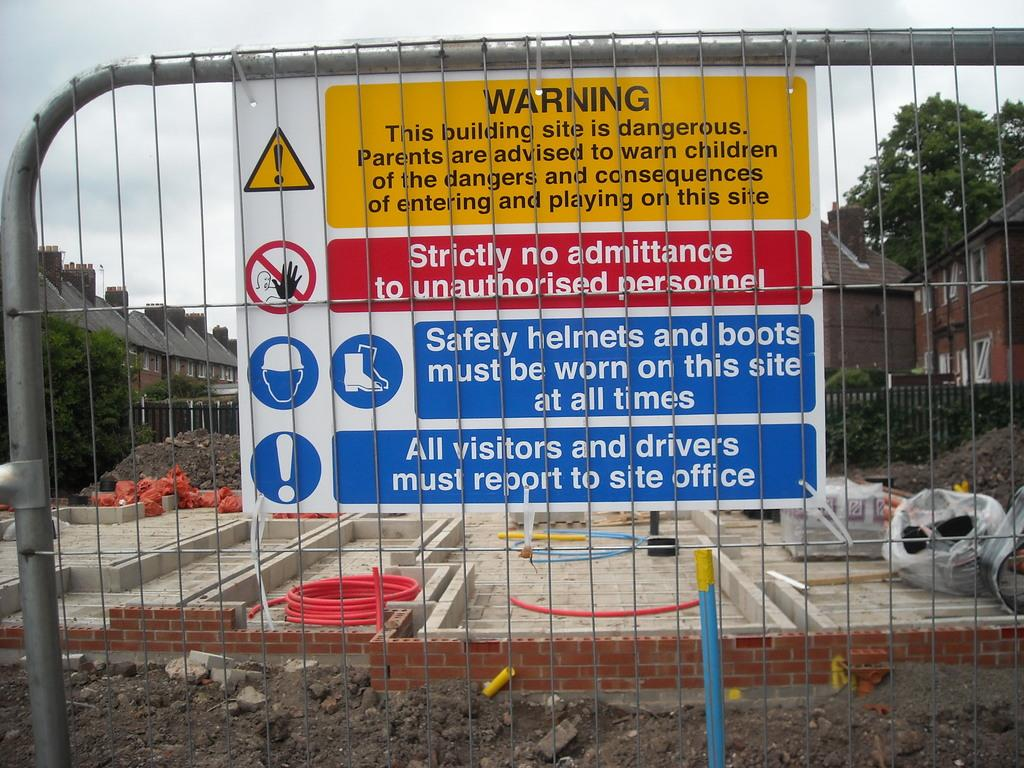<image>
Create a compact narrative representing the image presented. A warning sign by a construction site includes no unauthorized personnel allowed. 